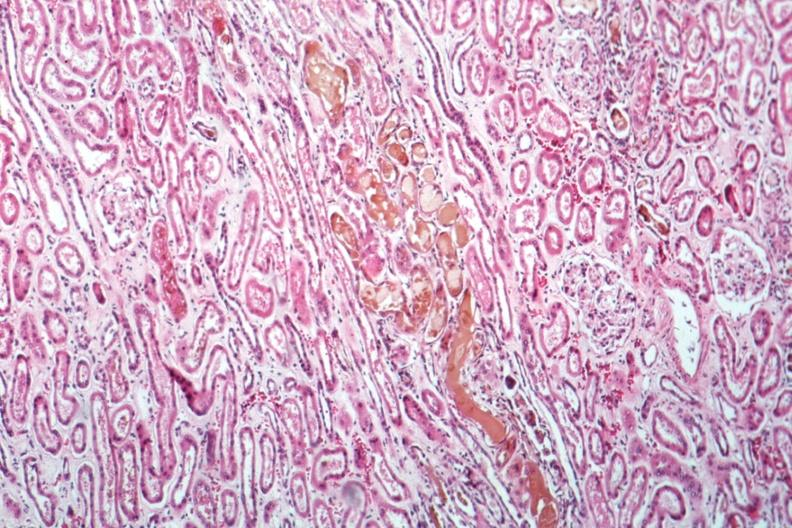s acute tubular necrosis present?
Answer the question using a single word or phrase. Yes 